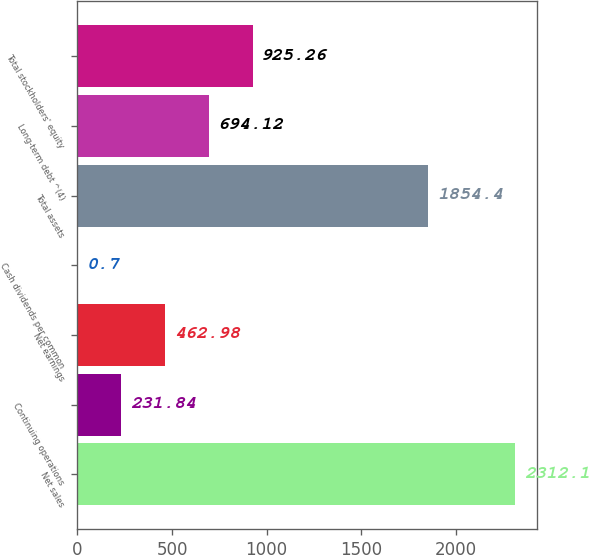Convert chart to OTSL. <chart><loc_0><loc_0><loc_500><loc_500><bar_chart><fcel>Net sales<fcel>Continuing operations<fcel>Net earnings<fcel>Cash dividends per common<fcel>Total assets<fcel>Long-term debt ^(4)<fcel>Total stockholders' equity<nl><fcel>2312.1<fcel>231.84<fcel>462.98<fcel>0.7<fcel>1854.4<fcel>694.12<fcel>925.26<nl></chart> 